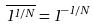Convert formula to latex. <formula><loc_0><loc_0><loc_500><loc_500>\overline { 1 ^ { 1 / N } } = 1 ^ { - 1 / N }</formula> 